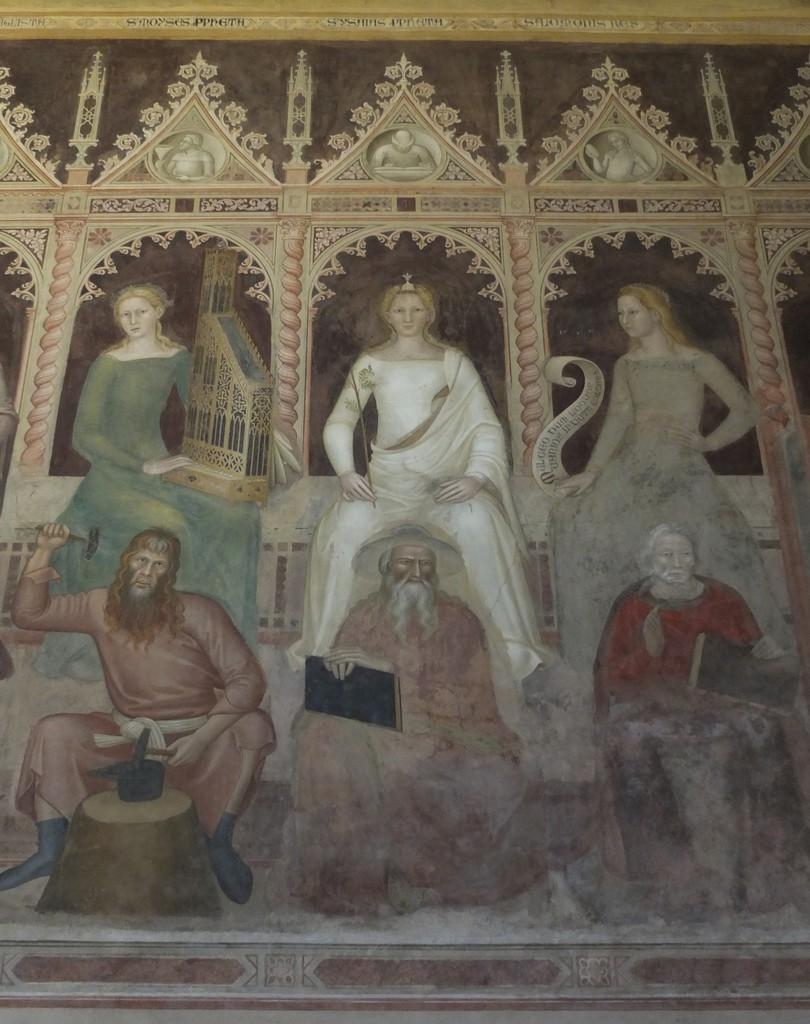What type of artwork is depicted in the image? There are human paintings in the image. What is the background of the human paintings? There is a wall with a design in the image. What type of level is being used to measure the height of the skirt in the image? There is no level or skirt present in the image; it only features human paintings and a wall with a design. 